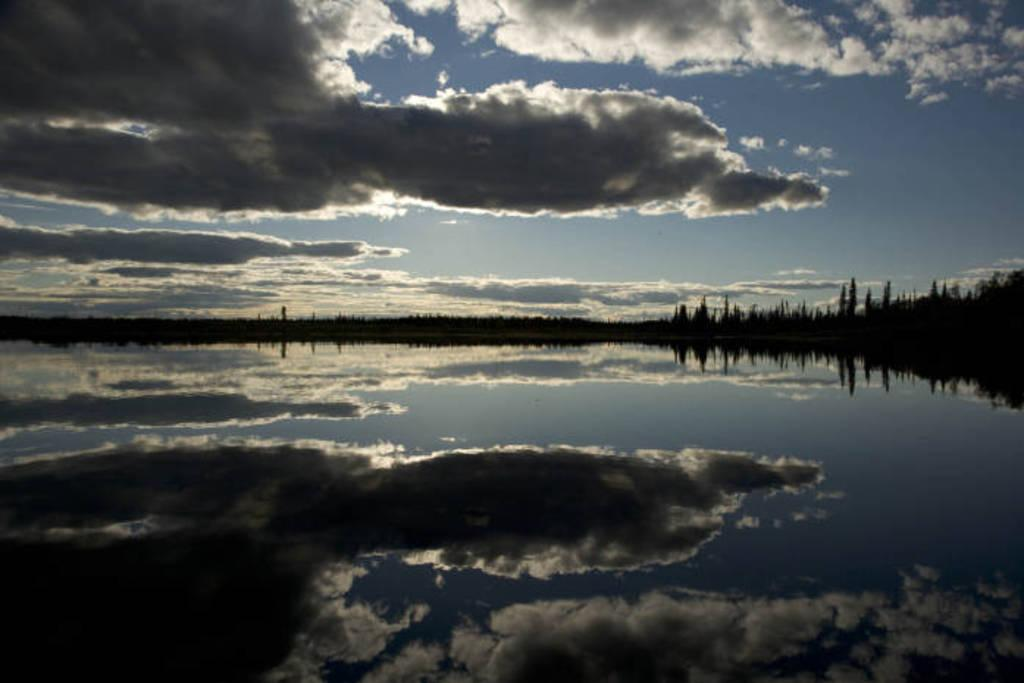What is visible in the image? Water, trees, and the sky are visible in the image. Can you describe the sky in the image? The sky appears to be cloudy in the image. What type of vegetation is present in the image? Trees are present in the image. Where is the uncle sitting with his doll in the image? There is no uncle or doll present in the image. What type of cart can be seen in the image? There is no cart present in the image. 